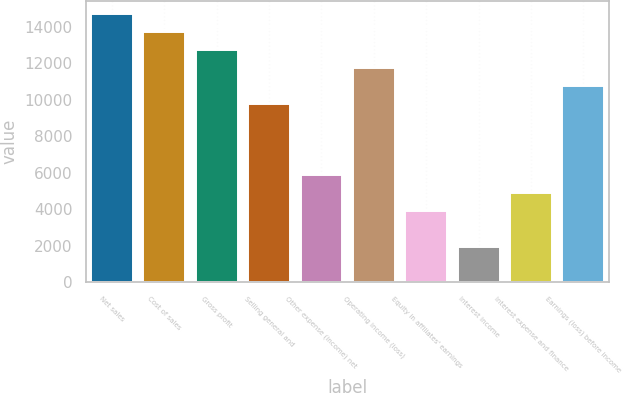Convert chart. <chart><loc_0><loc_0><loc_500><loc_500><bar_chart><fcel>Net sales<fcel>Cost of sales<fcel>Gross profit<fcel>Selling general and<fcel>Other expense (income) net<fcel>Operating income (loss)<fcel>Equity in affiliates' earnings<fcel>Interest income<fcel>Interest expense and finance<fcel>Earnings (loss) before income<nl><fcel>14697.9<fcel>13718.2<fcel>12738.4<fcel>9799.28<fcel>5880.4<fcel>11758.7<fcel>3920.96<fcel>1961.52<fcel>4900.68<fcel>10779<nl></chart> 